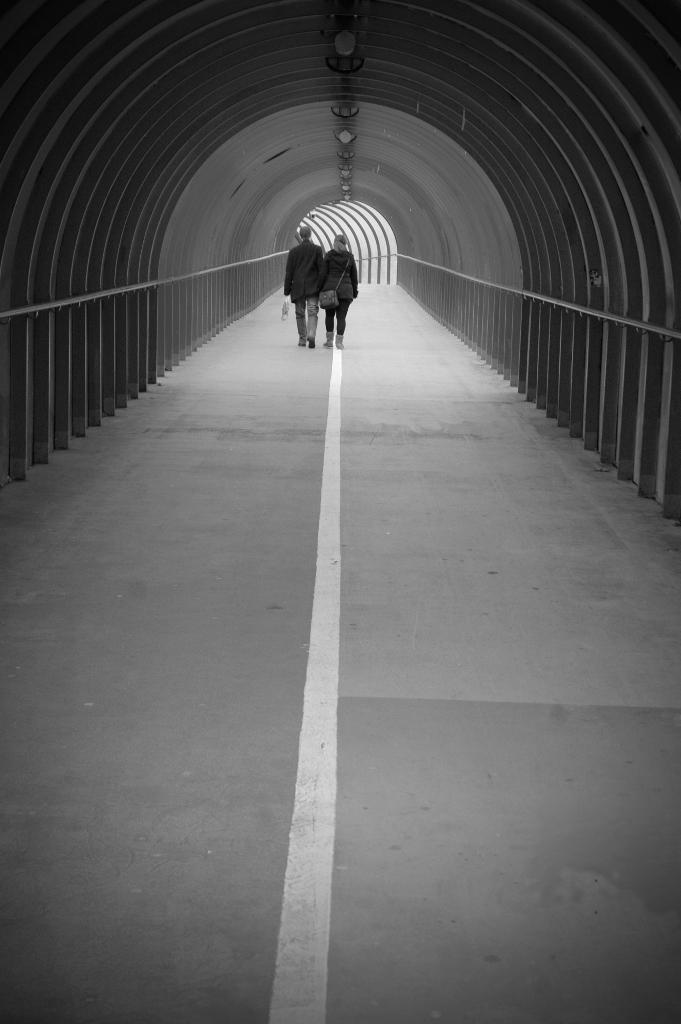How would you summarize this image in a sentence or two? In this image there is a couple who are walking on the road. They are inside the tunnel. It is the black and white image. 